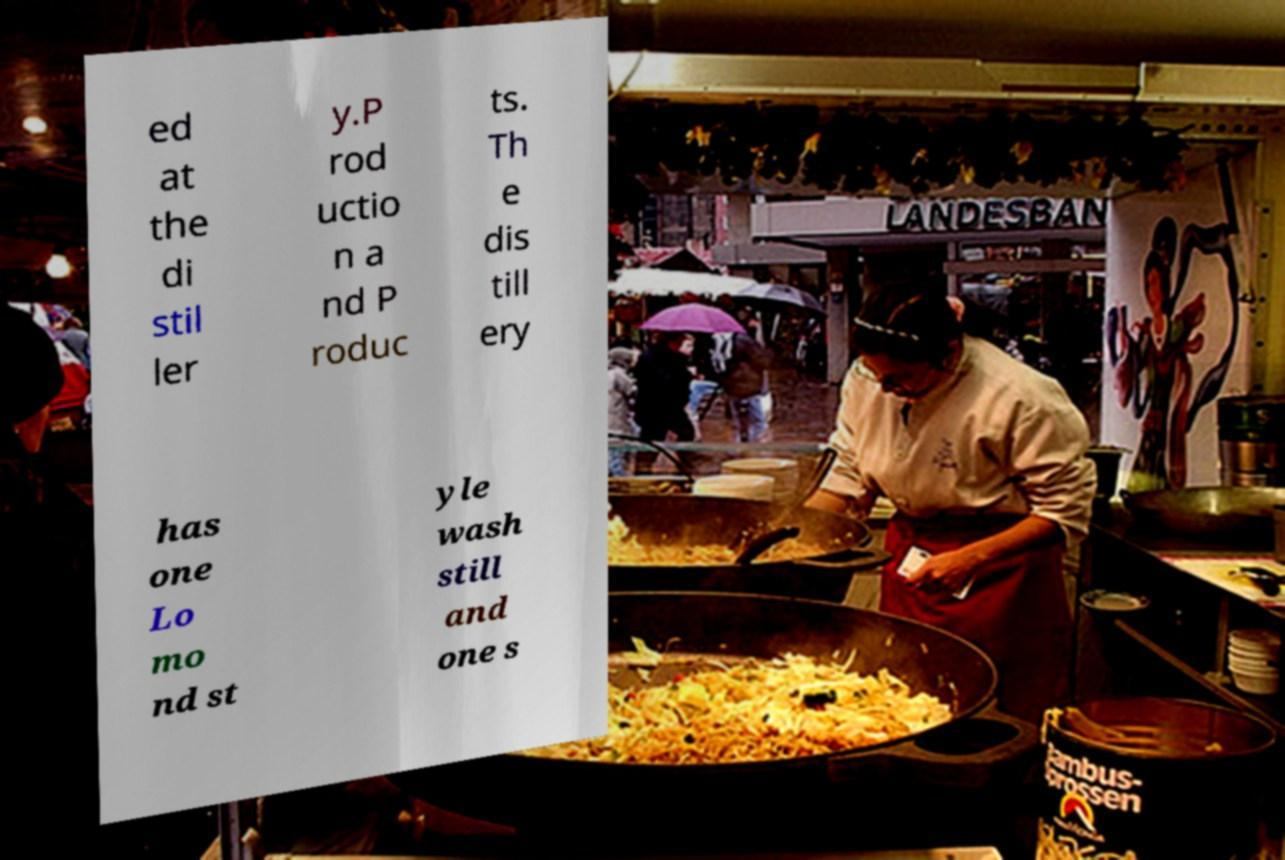Could you extract and type out the text from this image? ed at the di stil ler y.P rod uctio n a nd P roduc ts. Th e dis till ery has one Lo mo nd st yle wash still and one s 